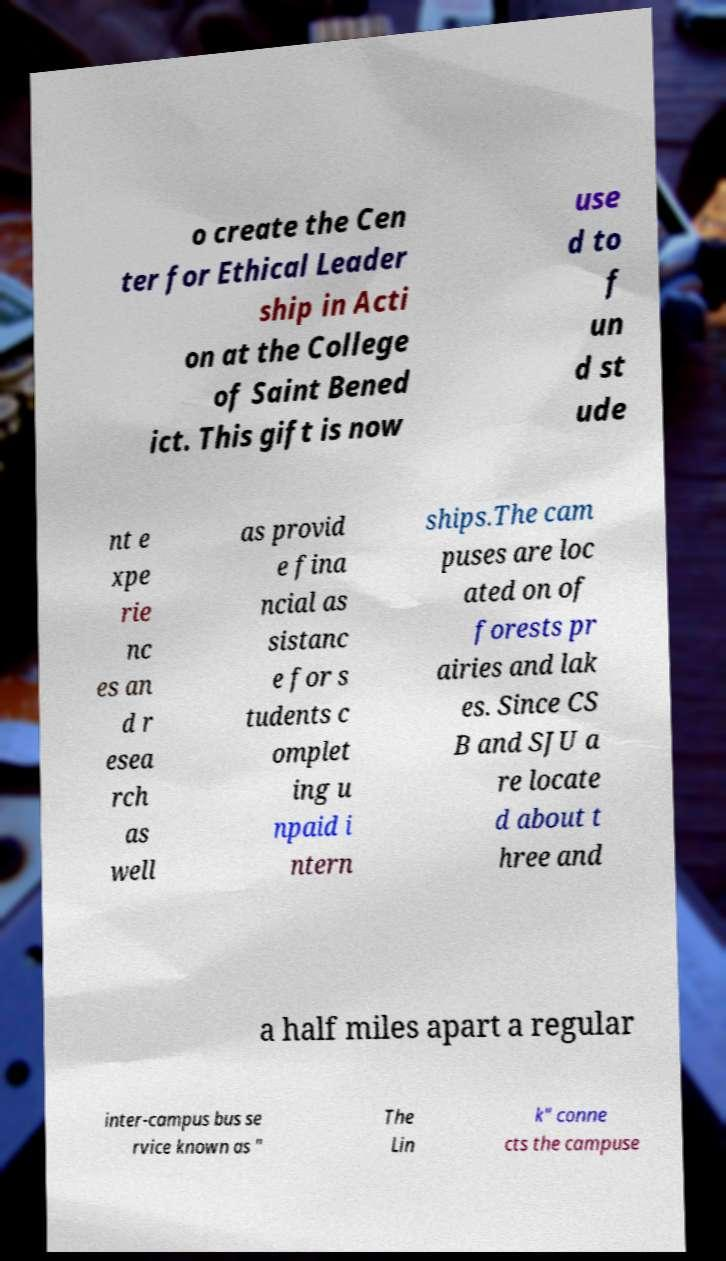I need the written content from this picture converted into text. Can you do that? o create the Cen ter for Ethical Leader ship in Acti on at the College of Saint Bened ict. This gift is now use d to f un d st ude nt e xpe rie nc es an d r esea rch as well as provid e fina ncial as sistanc e for s tudents c omplet ing u npaid i ntern ships.The cam puses are loc ated on of forests pr airies and lak es. Since CS B and SJU a re locate d about t hree and a half miles apart a regular inter-campus bus se rvice known as " The Lin k" conne cts the campuse 